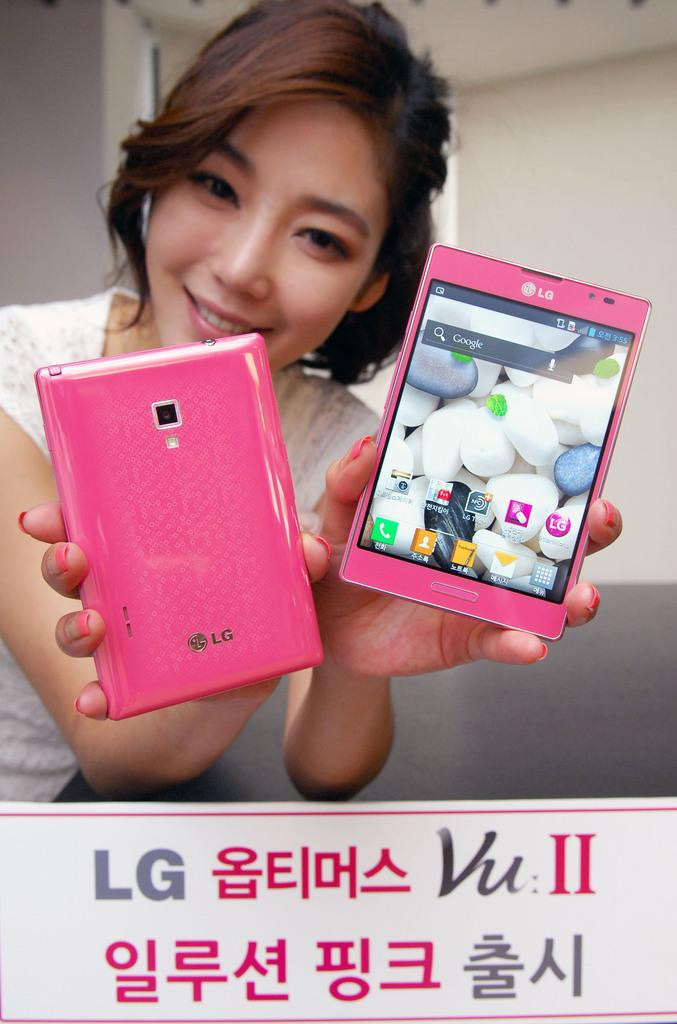<image>
Describe the image concisely. A girl shows the front and back of a pink LG model phone. 